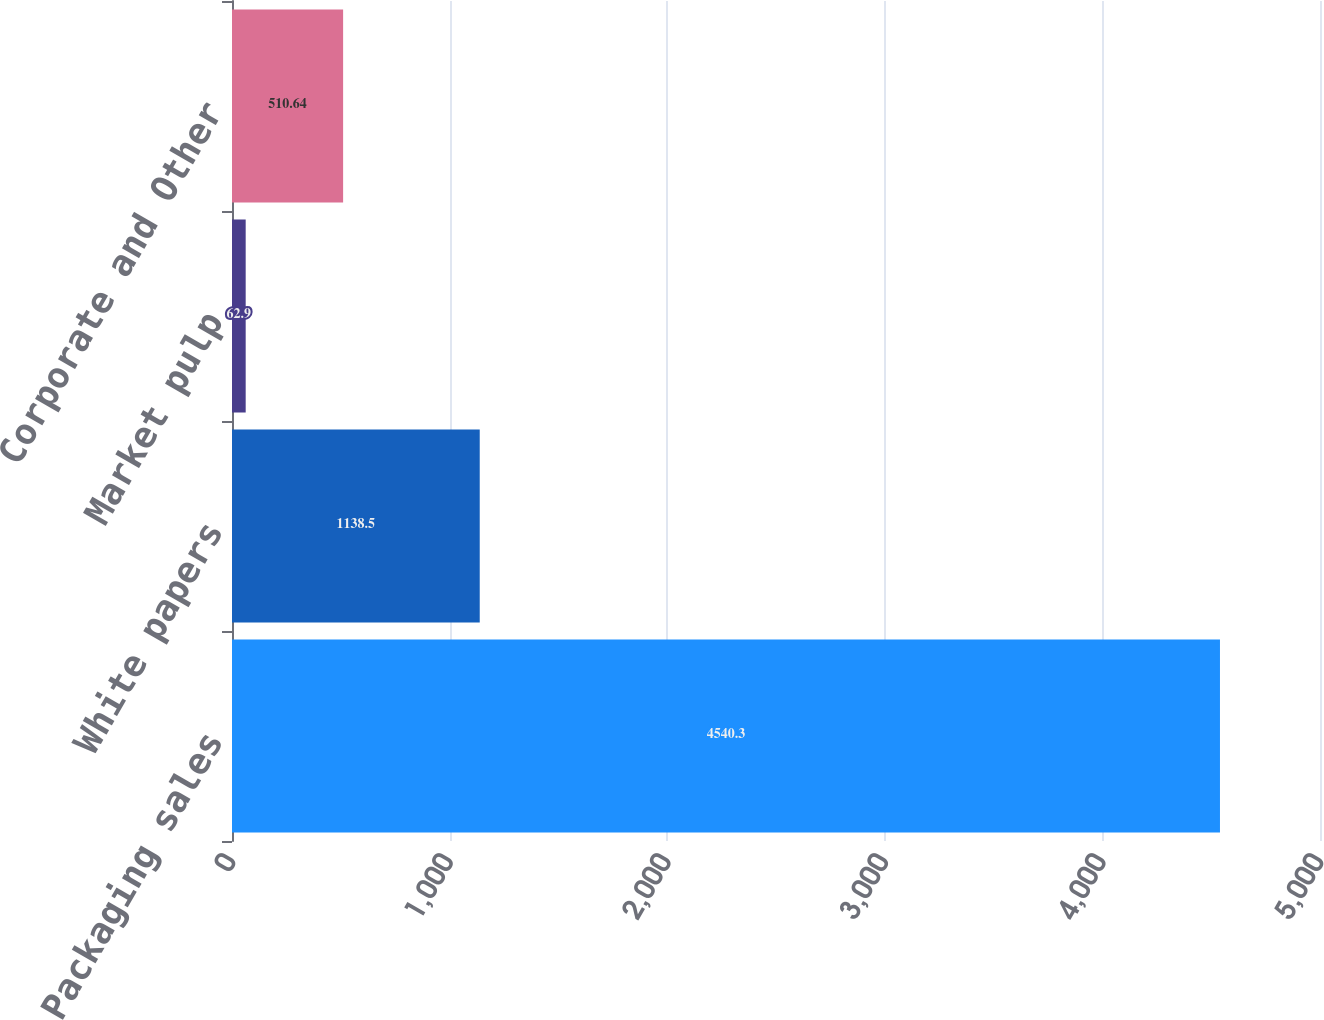<chart> <loc_0><loc_0><loc_500><loc_500><bar_chart><fcel>Packaging sales<fcel>White papers<fcel>Market pulp<fcel>Corporate and Other<nl><fcel>4540.3<fcel>1138.5<fcel>62.9<fcel>510.64<nl></chart> 